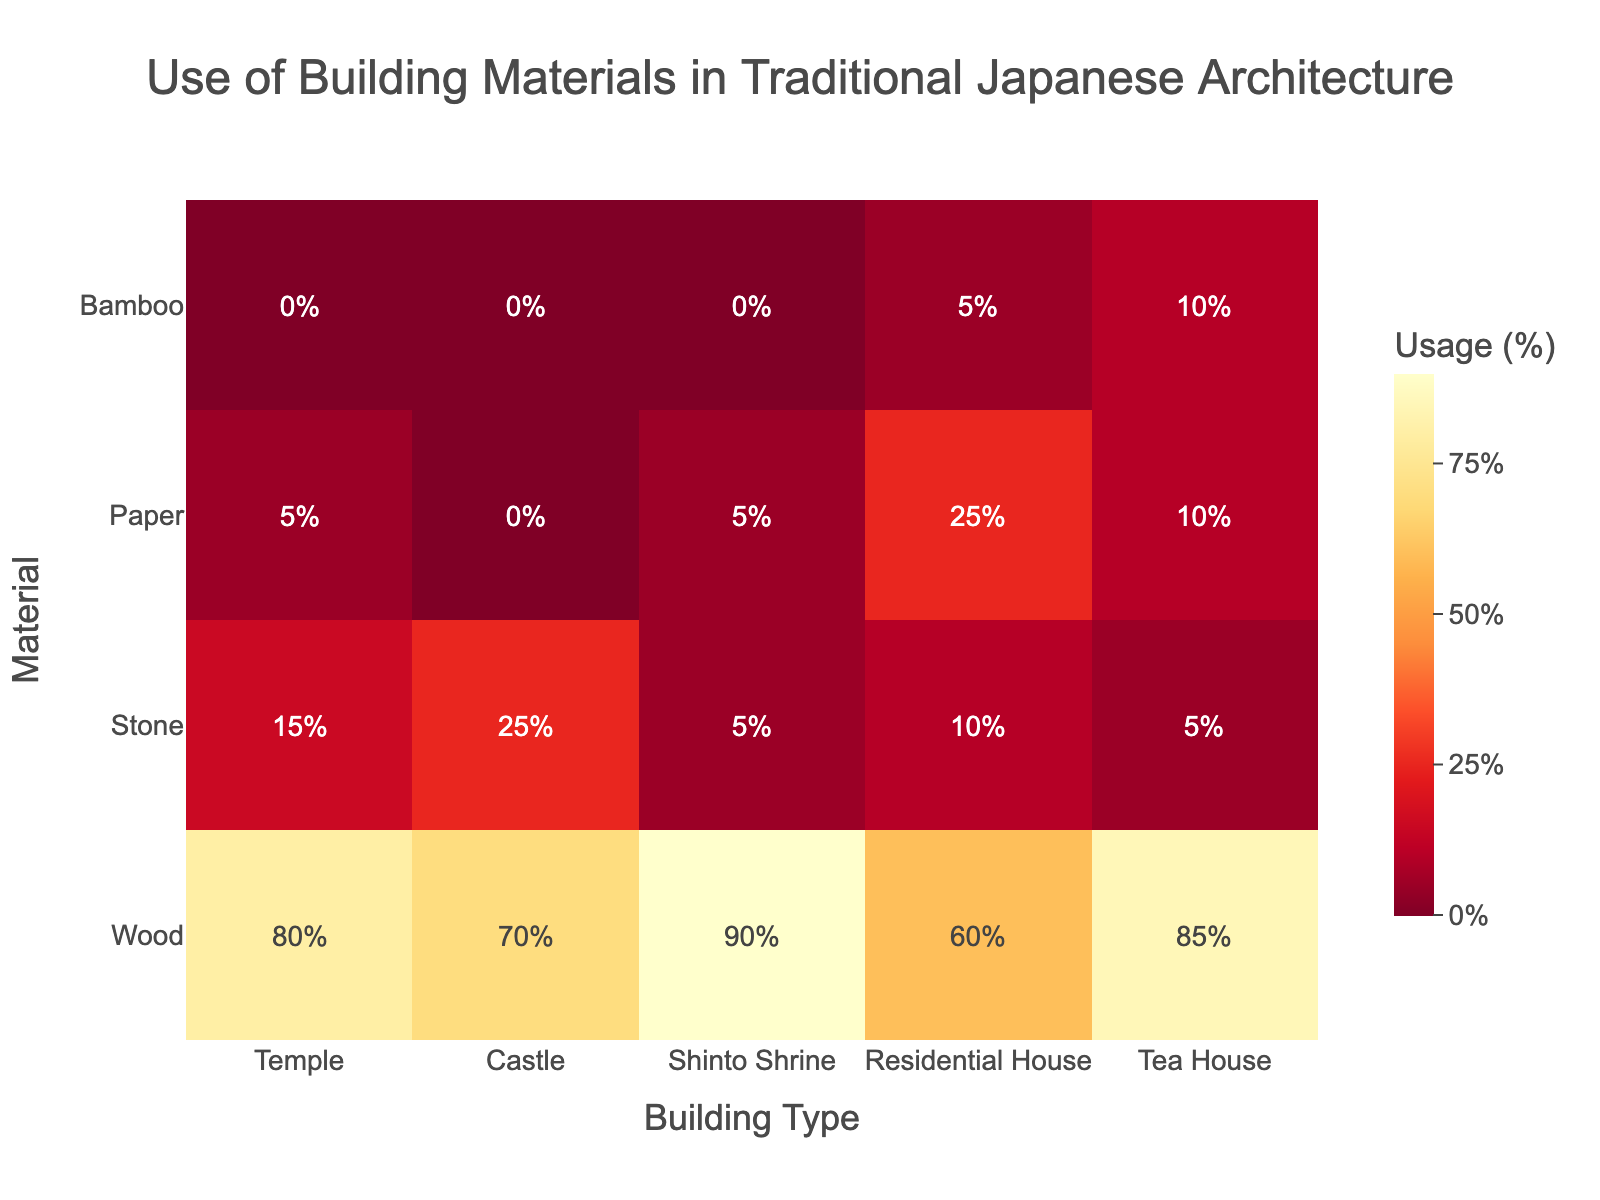What is the most frequently used material in Shinto Shrines according to the heatmap? The heatmap shows that wood has the highest percentage (90%) in Shinto Shrines, indicating it is the most frequently used material.
Answer: Wood Which building type uses the least amount of bamboo? The heatmap shows that Temple, Castle, and Shinto Shrine all have 0% usage of bamboo. Hence, these three types use the least amount of bamboo.
Answer: Temple, Castle, Shinto Shrine What is the percentage difference in the use of wood between Temples and Residential Houses? The use of wood in Temples is 80%, while in Residential Houses, it is 60%. The difference is 80% - 60% = 20%.
Answer: 20% How many building types use paper in their construction, according to the heatmap? The heatmap shows paper usage for Temples, Shinto Shrines, Residential Houses, and Tea Houses. This totals 4 building types.
Answer: 4 Which material is used exclusively in one type of building? Bamboo is used exclusively in Residential Houses (5%) and Tea Houses (10%) according to the heatmap.
Answer: Bamboo What is the average usage of stone across all building types? Stone use in Temples (15%), Castles (25%), Shinto Shrines (5%), Residential Houses (10%), and Tea Houses (5%). The average is (15 + 25 + 5 + 10 + 5) / 5 = 12%.
Answer: 12% Which building type shows the highest percentage usage of any material in the heatmap? Shinto Shrines show 90% usage of wood, which is the highest percentage for any material in any building type.
Answer: Shinto Shrines Combine the percentages of paper and bamboo usage in Tea Houses. What is the total? The heatmap shows 10% usage of both paper and bamboo in Tea Houses. The total is 10% + 10% = 20%.
Answer: 20% If you sum all the percentages of material use in Castles, what is the total percentage? The heatmap shows wood (70%), stone (25%), paper (0%), and bamboo (0%) in Castles. The sum is 70% + 25% + 0% + 0% = 95%.
Answer: 95% 